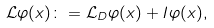Convert formula to latex. <formula><loc_0><loc_0><loc_500><loc_500>\mathcal { L } \varphi ( x ) & \colon = \mathcal { L } _ { D } \varphi ( x ) + I \varphi ( x ) ,</formula> 